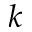Convert formula to latex. <formula><loc_0><loc_0><loc_500><loc_500>k</formula> 